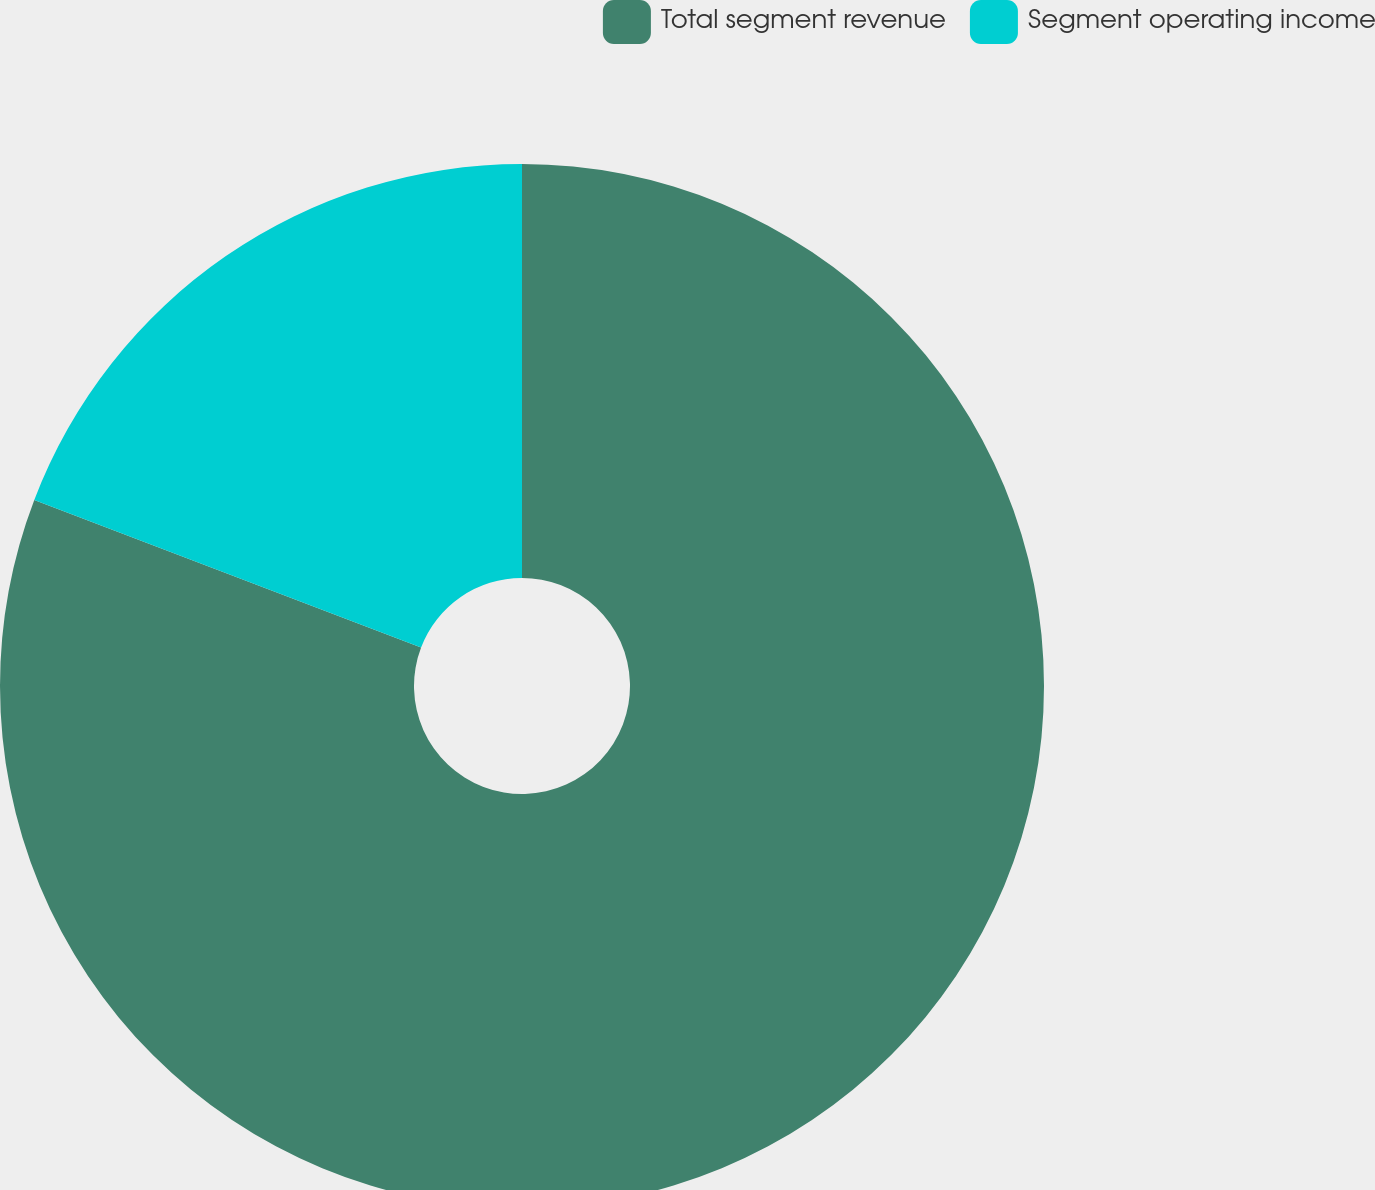Convert chart. <chart><loc_0><loc_0><loc_500><loc_500><pie_chart><fcel>Total segment revenue<fcel>Segment operating income<nl><fcel>80.8%<fcel>19.2%<nl></chart> 